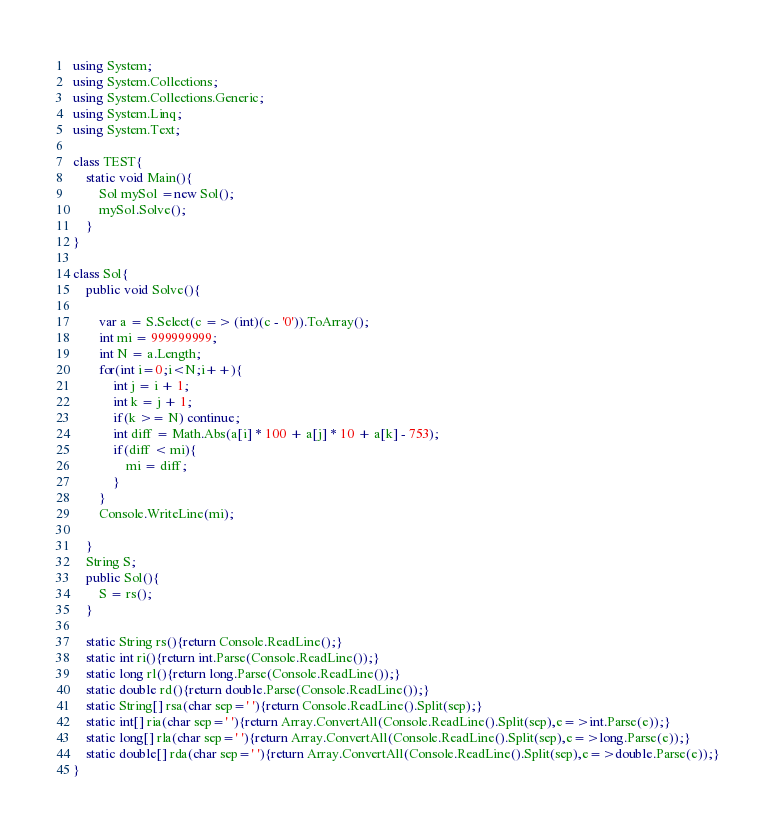Convert code to text. <code><loc_0><loc_0><loc_500><loc_500><_C#_>using System;
using System.Collections;
using System.Collections.Generic;
using System.Linq;
using System.Text;

class TEST{
	static void Main(){
		Sol mySol =new Sol();
		mySol.Solve();
	}
}

class Sol{
	public void Solve(){
		
		var a = S.Select(c => (int)(c - '0')).ToArray();
		int mi = 999999999;
		int N = a.Length;
		for(int i=0;i<N;i++){
			int j = i + 1;
			int k = j + 1;
			if(k >= N) continue;
			int diff = Math.Abs(a[i] * 100 + a[j] * 10 + a[k] - 753);
			if(diff < mi){
				mi = diff;
			}
		}
		Console.WriteLine(mi);
		
	}
	String S;
	public Sol(){
		S = rs();
	}

	static String rs(){return Console.ReadLine();}
	static int ri(){return int.Parse(Console.ReadLine());}
	static long rl(){return long.Parse(Console.ReadLine());}
	static double rd(){return double.Parse(Console.ReadLine());}
	static String[] rsa(char sep=' '){return Console.ReadLine().Split(sep);}
	static int[] ria(char sep=' '){return Array.ConvertAll(Console.ReadLine().Split(sep),e=>int.Parse(e));}
	static long[] rla(char sep=' '){return Array.ConvertAll(Console.ReadLine().Split(sep),e=>long.Parse(e));}
	static double[] rda(char sep=' '){return Array.ConvertAll(Console.ReadLine().Split(sep),e=>double.Parse(e));}
}
</code> 